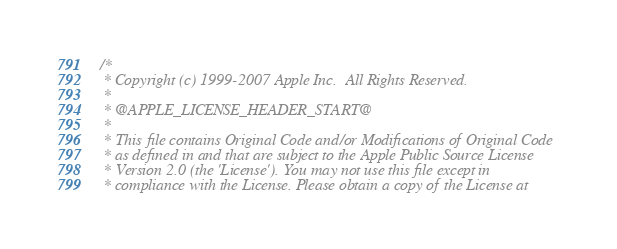Convert code to text. <code><loc_0><loc_0><loc_500><loc_500><_ObjectiveC_>/*
 * Copyright (c) 1999-2007 Apple Inc.  All Rights Reserved.
 * 
 * @APPLE_LICENSE_HEADER_START@
 * 
 * This file contains Original Code and/or Modifications of Original Code
 * as defined in and that are subject to the Apple Public Source License
 * Version 2.0 (the 'License'). You may not use this file except in
 * compliance with the License. Please obtain a copy of the License at</code> 